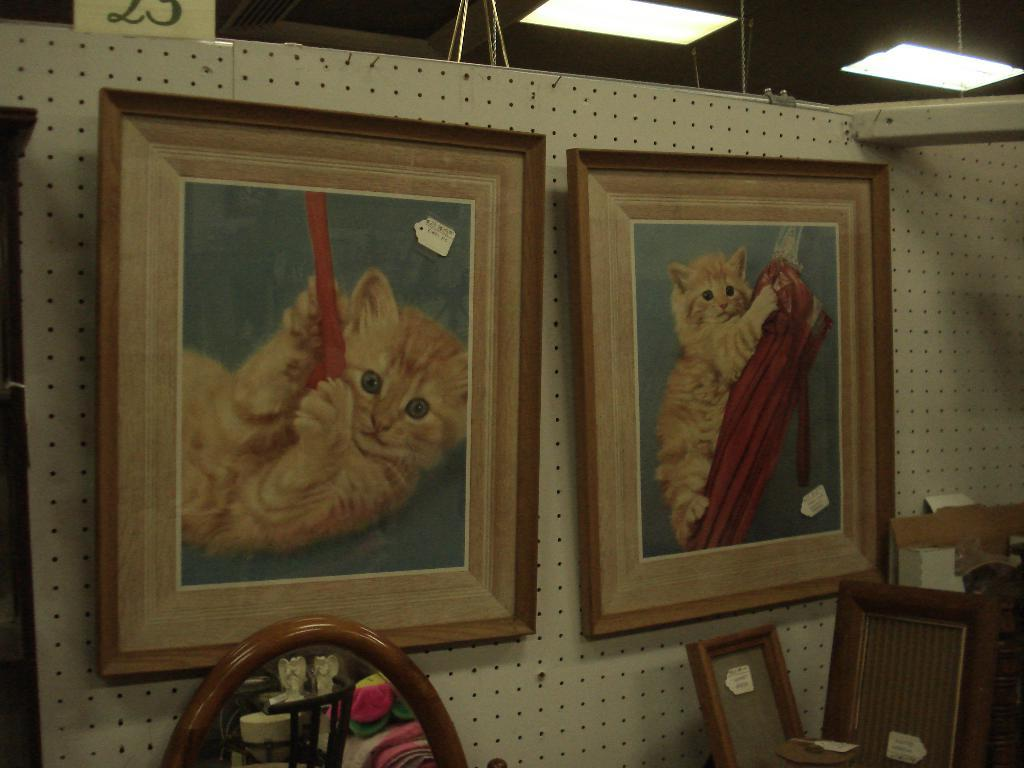What type of images are displayed on the wall in the image? There are two cat photos on the wall. What objects are in the foreground of the image? There are chairs in the foreground. What is located above the chairs in the image? There is a roof with lights. Can you see any cherries on the chairs in the image? There are no cherries present on the chairs in the image. What type of instrument is being played in the image? There is no instrument being played in the image; the focus is on the cat photos, chairs, and roof with lights. 